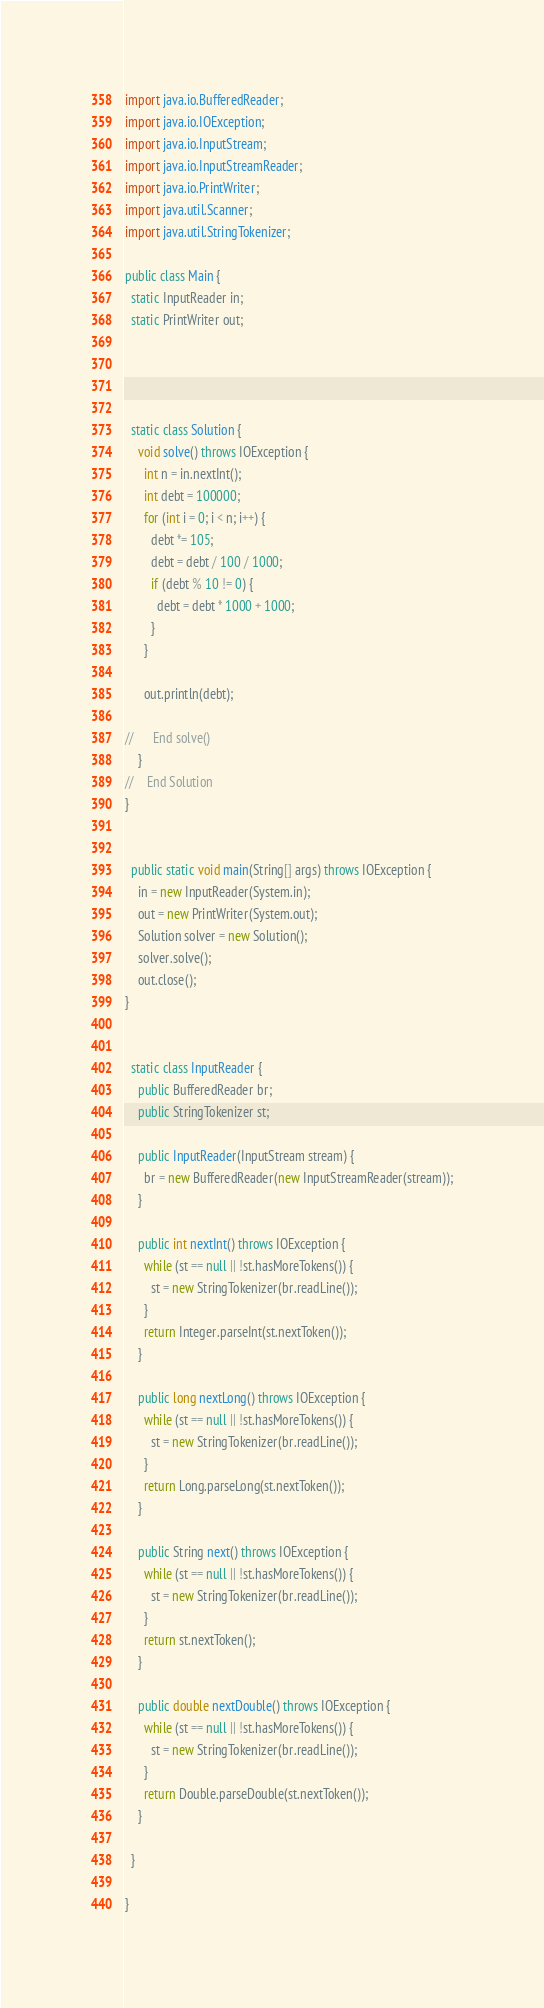Convert code to text. <code><loc_0><loc_0><loc_500><loc_500><_Java_>import java.io.BufferedReader;
import java.io.IOException;
import java.io.InputStream;
import java.io.InputStreamReader;
import java.io.PrintWriter;
import java.util.Scanner;
import java.util.StringTokenizer;

public class Main {
  static InputReader in;
  static PrintWriter out;




  static class Solution {
    void solve() throws IOException {
      int n = in.nextInt();
      int debt = 100000;
      for (int i = 0; i < n; i++) {
        debt *= 105;
        debt = debt / 100 / 1000;
        if (debt % 10 != 0) {          
          debt = debt * 1000 + 1000;
        }
      }
      
      out.println(debt);
      
//      End solve()
    }
//    End Solution
}


  public static void main(String[] args) throws IOException {
    in = new InputReader(System.in);
    out = new PrintWriter(System.out);
    Solution solver = new Solution();
    solver.solve();
    out.close();
}


  static class InputReader {
    public BufferedReader br;
    public StringTokenizer st;

    public InputReader(InputStream stream) {
      br = new BufferedReader(new InputStreamReader(stream));
    }

    public int nextInt() throws IOException {
      while (st == null || !st.hasMoreTokens()) {
        st = new StringTokenizer(br.readLine());
      }
      return Integer.parseInt(st.nextToken());
    }

    public long nextLong() throws IOException {
      while (st == null || !st.hasMoreTokens()) {
        st = new StringTokenizer(br.readLine());
      }
      return Long.parseLong(st.nextToken());
    }

    public String next() throws IOException {
      while (st == null || !st.hasMoreTokens()) {
        st = new StringTokenizer(br.readLine());
      }
      return st.nextToken();
    }

    public double nextDouble() throws IOException {
      while (st == null || !st.hasMoreTokens()) {
        st = new StringTokenizer(br.readLine());
      }
      return Double.parseDouble(st.nextToken());
    }

  }

}</code> 